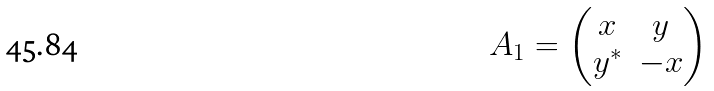<formula> <loc_0><loc_0><loc_500><loc_500>A _ { 1 } = \begin{pmatrix} x & y \\ y ^ { \ast } & - x \end{pmatrix}</formula> 